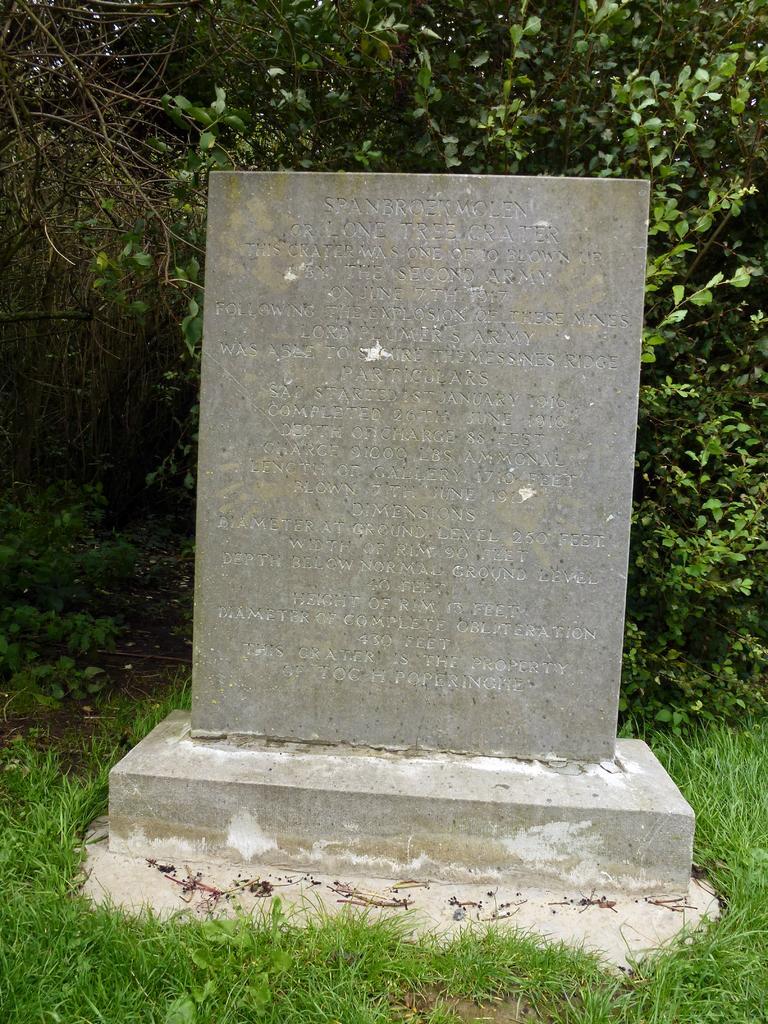Describe this image in one or two sentences. In this image we can see a memorial on a platform on the ground. In the background there are trees, plants and grass on the ground. 